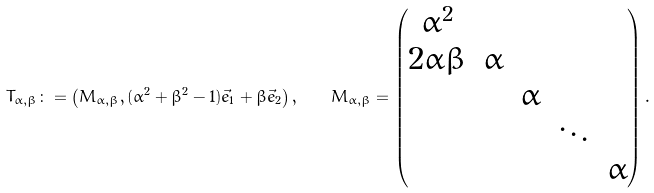<formula> <loc_0><loc_0><loc_500><loc_500>T _ { \alpha , \beta } \colon = \left ( M _ { \alpha , \beta } , ( \alpha ^ { 2 } + \beta ^ { 2 } - 1 ) \vec { e } _ { 1 } + \beta \vec { e } _ { 2 } \right ) , \quad M _ { \alpha , \beta } = \begin{pmatrix} \alpha ^ { 2 } & \\ 2 \alpha \beta & \alpha & \\ & & \alpha \\ & & & \ddots \\ & & & & \alpha \end{pmatrix} .</formula> 